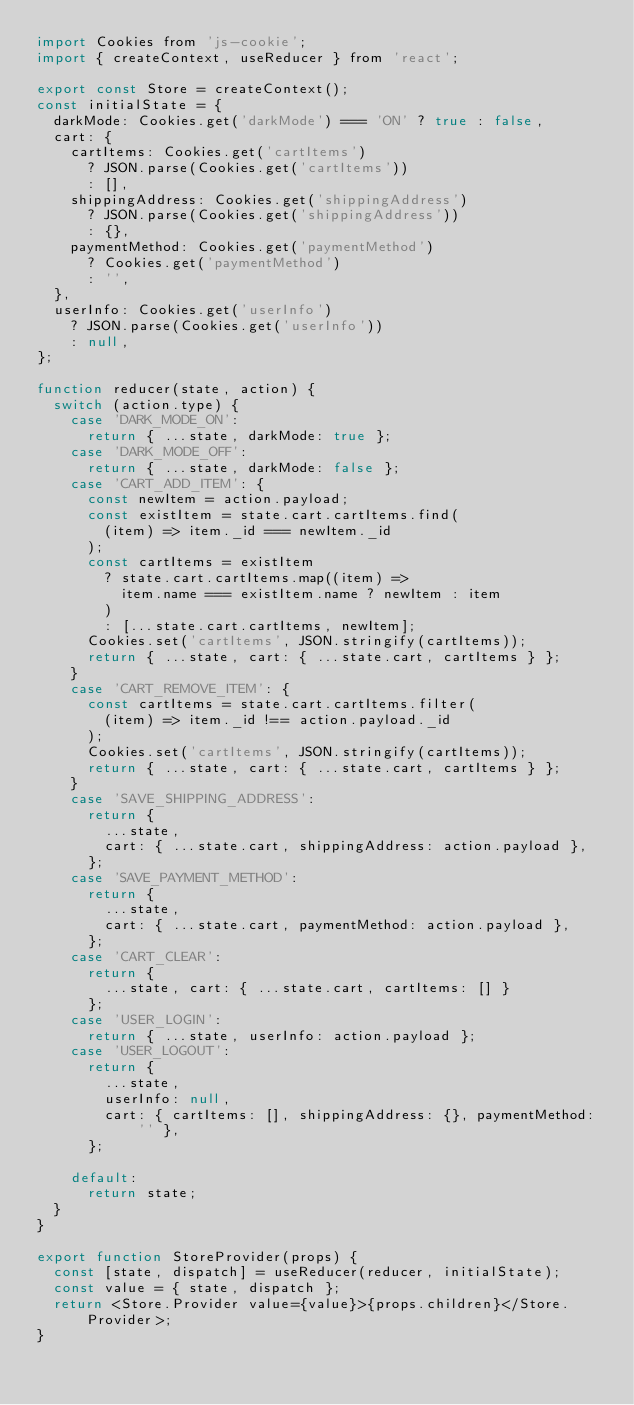<code> <loc_0><loc_0><loc_500><loc_500><_JavaScript_>import Cookies from 'js-cookie';
import { createContext, useReducer } from 'react';

export const Store = createContext();
const initialState = {
  darkMode: Cookies.get('darkMode') === 'ON' ? true : false,
  cart: {
    cartItems: Cookies.get('cartItems')
      ? JSON.parse(Cookies.get('cartItems'))
      : [],
    shippingAddress: Cookies.get('shippingAddress')
      ? JSON.parse(Cookies.get('shippingAddress'))
      : {},
    paymentMethod: Cookies.get('paymentMethod')
      ? Cookies.get('paymentMethod')
      : '',
  },
  userInfo: Cookies.get('userInfo')
    ? JSON.parse(Cookies.get('userInfo'))
    : null,
};

function reducer(state, action) {
  switch (action.type) {
    case 'DARK_MODE_ON':
      return { ...state, darkMode: true };
    case 'DARK_MODE_OFF':
      return { ...state, darkMode: false };
    case 'CART_ADD_ITEM': {
      const newItem = action.payload;
      const existItem = state.cart.cartItems.find(
        (item) => item._id === newItem._id
      );
      const cartItems = existItem
        ? state.cart.cartItems.map((item) =>
          item.name === existItem.name ? newItem : item
        )
        : [...state.cart.cartItems, newItem];
      Cookies.set('cartItems', JSON.stringify(cartItems));
      return { ...state, cart: { ...state.cart, cartItems } };
    }
    case 'CART_REMOVE_ITEM': {
      const cartItems = state.cart.cartItems.filter(
        (item) => item._id !== action.payload._id
      );
      Cookies.set('cartItems', JSON.stringify(cartItems));
      return { ...state, cart: { ...state.cart, cartItems } };
    }
    case 'SAVE_SHIPPING_ADDRESS':
      return {
        ...state,
        cart: { ...state.cart, shippingAddress: action.payload },
      };
    case 'SAVE_PAYMENT_METHOD':
      return {
        ...state,
        cart: { ...state.cart, paymentMethod: action.payload },
      };
    case 'CART_CLEAR':
      return {
        ...state, cart: { ...state.cart, cartItems: [] }
      };
    case 'USER_LOGIN':
      return { ...state, userInfo: action.payload };
    case 'USER_LOGOUT':
      return {
        ...state,
        userInfo: null,
        cart: { cartItems: [], shippingAddress: {}, paymentMethod: '' },
      };

    default:
      return state;
  }
}

export function StoreProvider(props) {
  const [state, dispatch] = useReducer(reducer, initialState);
  const value = { state, dispatch };
  return <Store.Provider value={value}>{props.children}</Store.Provider>;
}</code> 